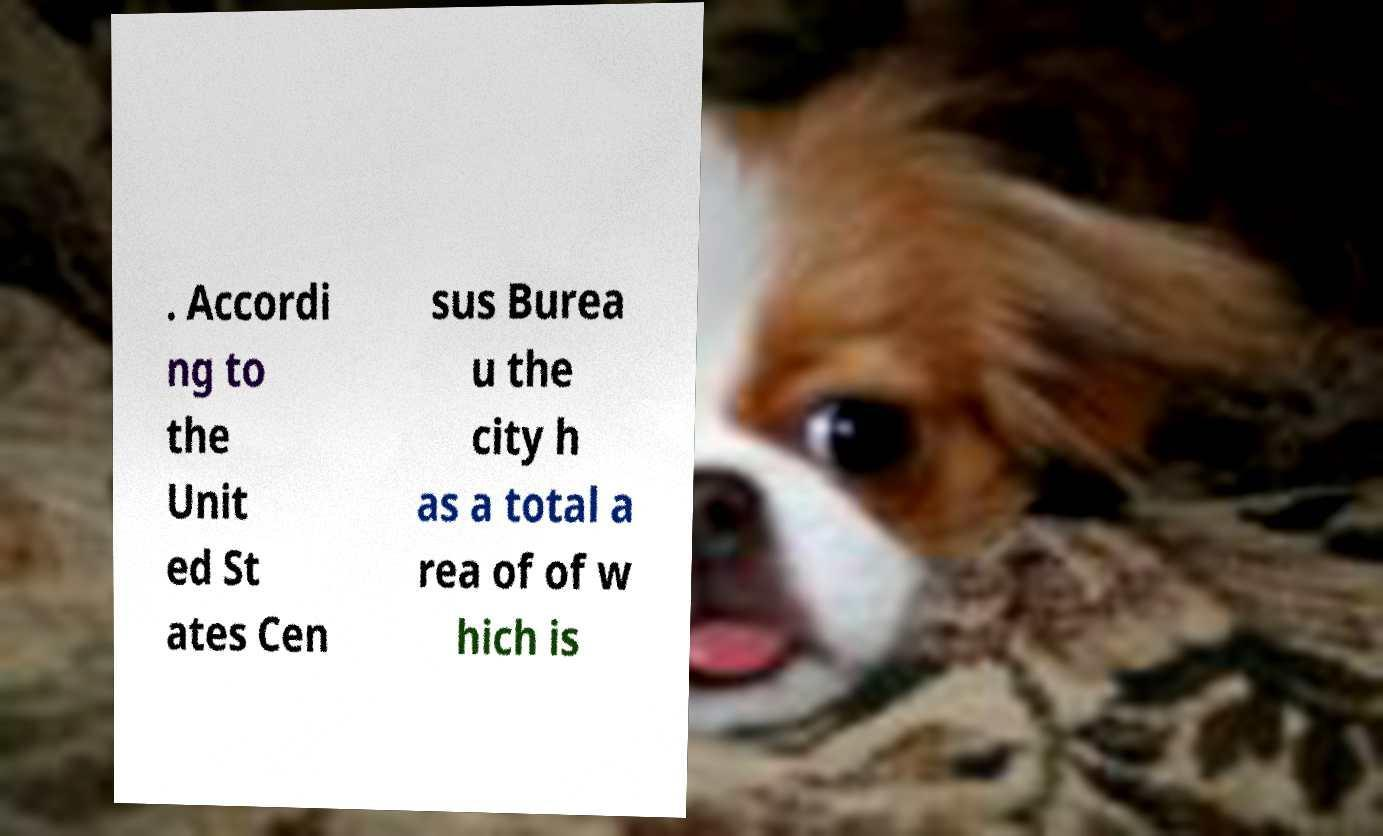Could you extract and type out the text from this image? . Accordi ng to the Unit ed St ates Cen sus Burea u the city h as a total a rea of of w hich is 